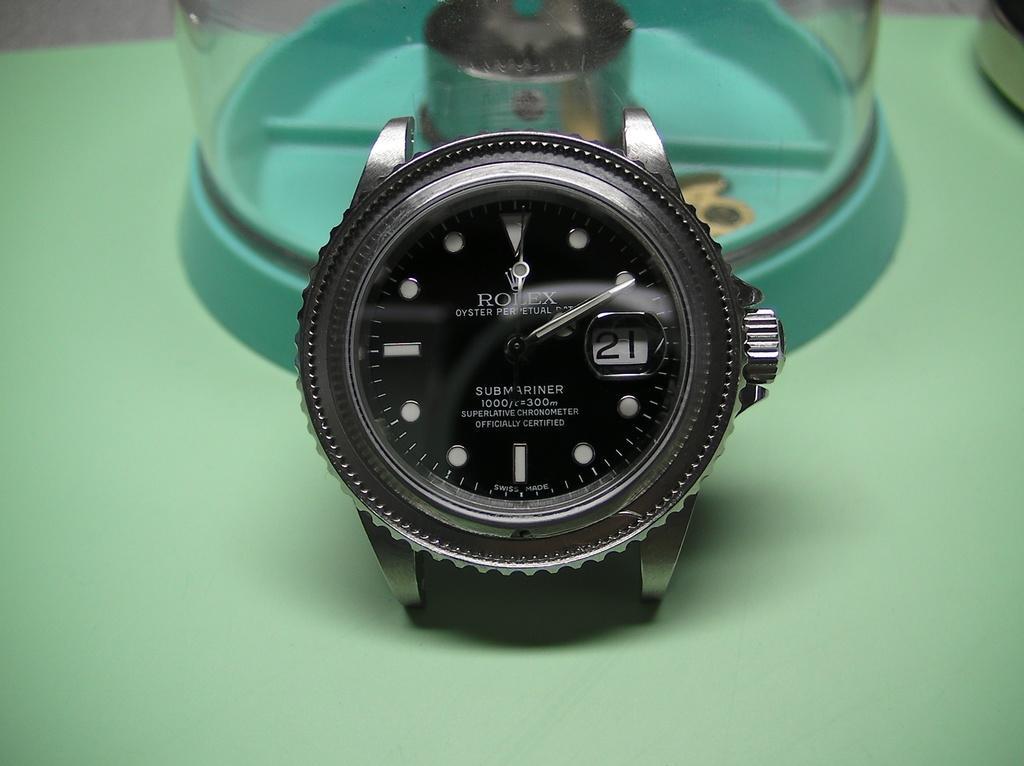Can you describe this image briefly? There is a watch in the foreground area of the image, there are some objects in the background. 